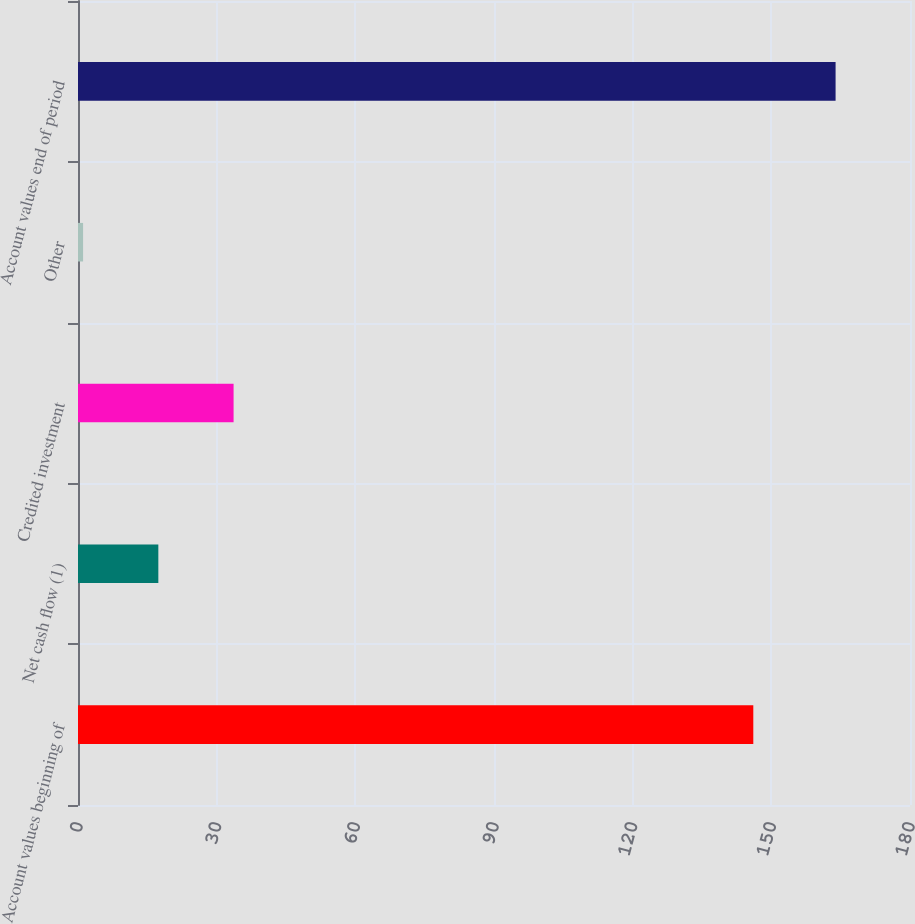Convert chart to OTSL. <chart><loc_0><loc_0><loc_500><loc_500><bar_chart><fcel>Account values beginning of<fcel>Net cash flow (1)<fcel>Credited investment<fcel>Other<fcel>Account values end of period<nl><fcel>146.1<fcel>17.38<fcel>33.66<fcel>1.1<fcel>163.9<nl></chart> 